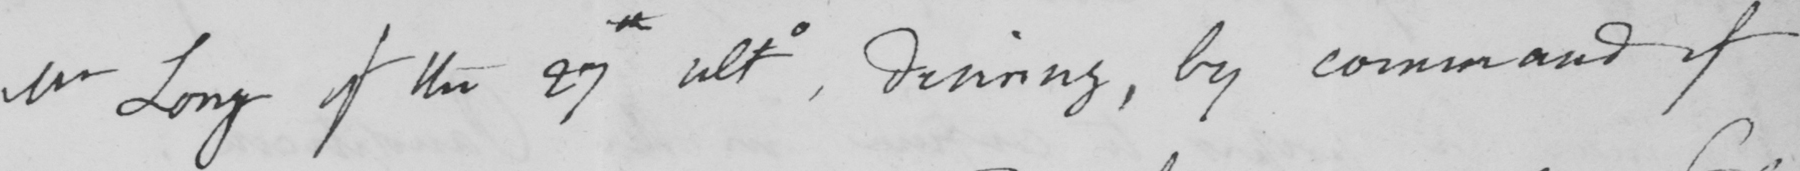Can you tell me what this handwritten text says? Mr Long of the 27th ulto, desiring, by command of 